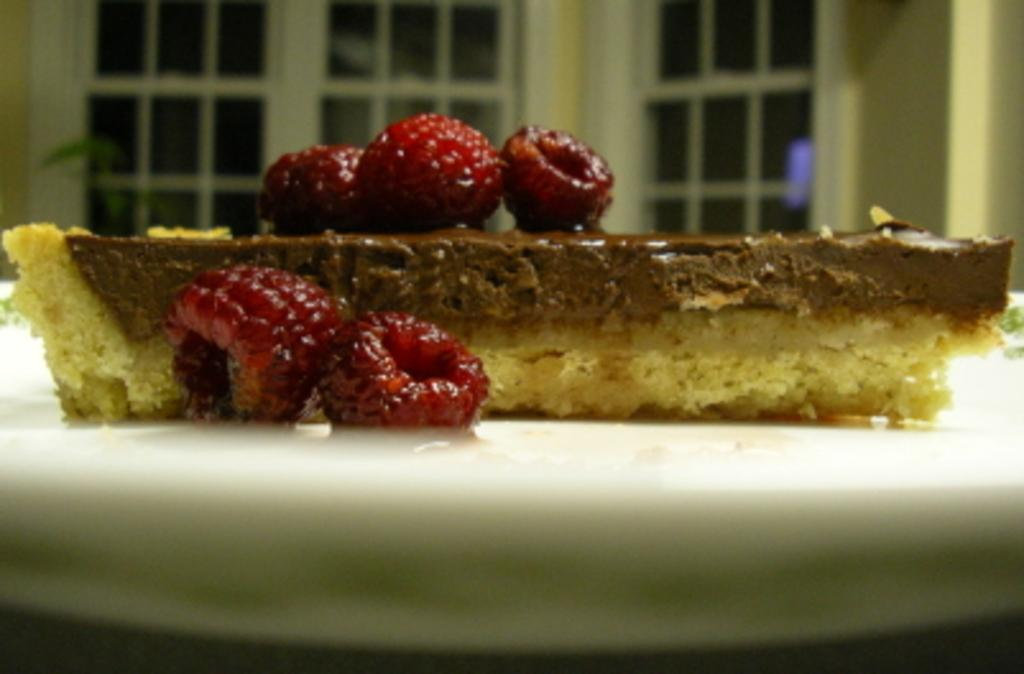What type of pastry is in the image? There is a chocolate pastry in the image. What fruit is present in the image? There are cherries in the image. On what is the pastry and cherries placed? The pastry and cherries are on a white plate. What can be seen in the background of the image? There is a white color glass window in the background of the image. What type of stage can be seen in the image? There is no stage present in the image; it features a chocolate pastry, cherries, and a white plate. Is anyone driving in the image? There is no indication of driving or any vehicles in the image. 